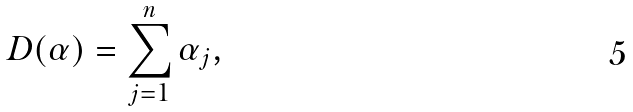<formula> <loc_0><loc_0><loc_500><loc_500>D ( \alpha ) = \sum _ { j = 1 } ^ { n } \alpha _ { j } ,</formula> 